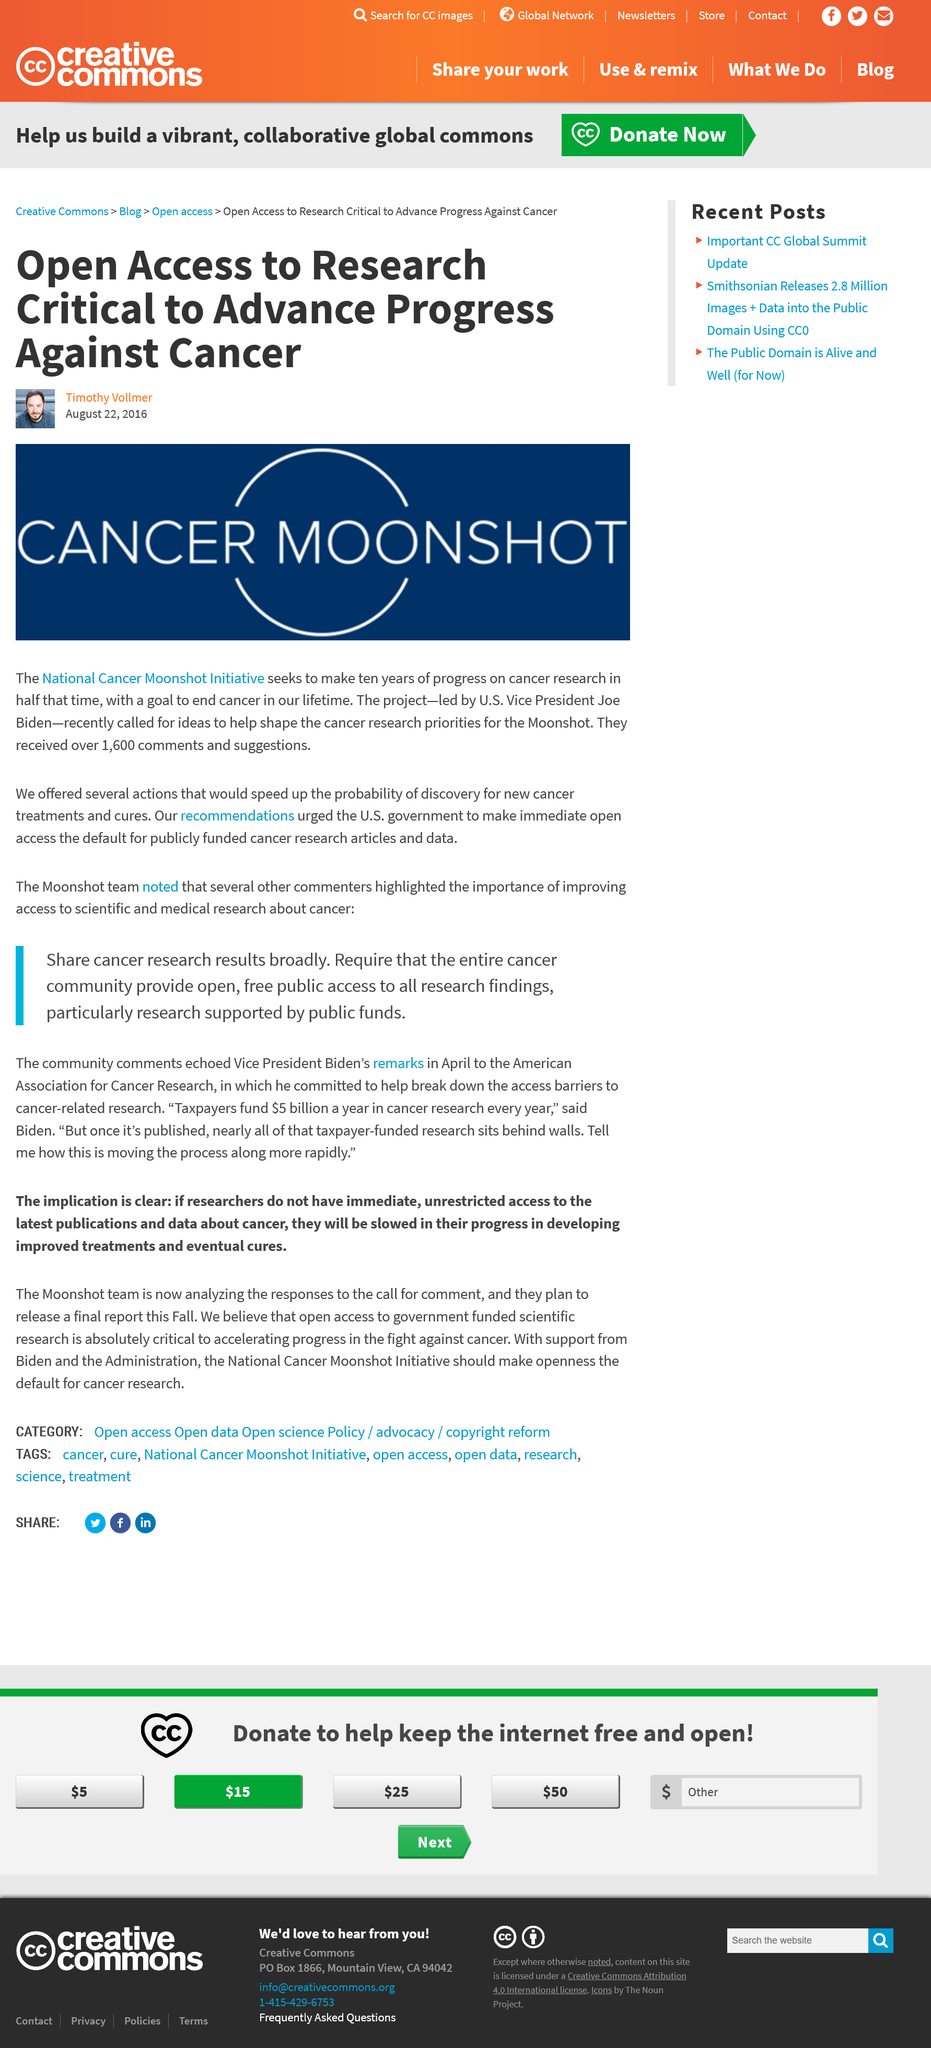Indicate a few pertinent items in this graphic. Vice President Joe Biden led the Cancer Moonshot project. The call for ideas regarding the National Cancer Moonshot Initiative received over 1600 comments and suggestions. On August 22, 2016, Timothy Vollmer wrote the article about the National Cancer Moonshot Initiative. 